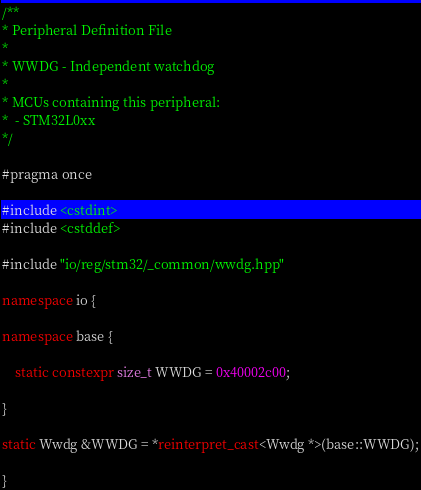<code> <loc_0><loc_0><loc_500><loc_500><_C++_>/**
* Peripheral Definition File
*
* WWDG - Independent watchdog
*
* MCUs containing this peripheral:
*  - STM32L0xx
*/

#pragma once

#include <cstdint>
#include <cstddef>

#include "io/reg/stm32/_common/wwdg.hpp"

namespace io {

namespace base {

    static constexpr size_t WWDG = 0x40002c00;

}

static Wwdg &WWDG = *reinterpret_cast<Wwdg *>(base::WWDG);

}
</code> 